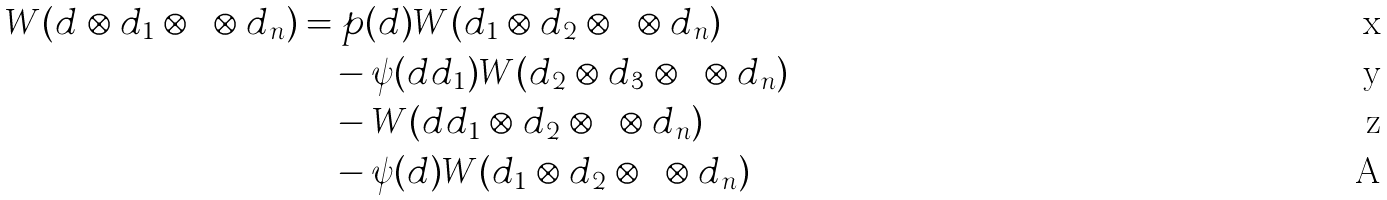<formula> <loc_0><loc_0><loc_500><loc_500>W ( d \otimes d _ { 1 } \otimes \cdots \otimes d _ { n } ) & = p ( d ) W ( d _ { 1 } \otimes d _ { 2 } \otimes \dots \otimes d _ { n } ) \\ & \quad - \psi ( d d _ { 1 } ) W ( d _ { 2 } \otimes d _ { 3 } \otimes \dots \otimes d _ { n } ) \\ & \quad - W ( d d _ { 1 } \otimes d _ { 2 } \otimes \cdots \otimes d _ { n } ) \\ & \quad - \psi ( d ) W ( d _ { 1 } \otimes d _ { 2 } \otimes \cdots \otimes d _ { n } )</formula> 